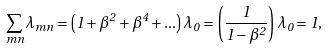<formula> <loc_0><loc_0><loc_500><loc_500>\sum _ { m n } \lambda _ { m n } = \left ( 1 + \beta ^ { 2 } + \beta ^ { 4 } + . . . \right ) \lambda _ { 0 } = \left ( \frac { 1 } { 1 - \beta ^ { 2 } } \right ) \lambda _ { 0 } = 1 ,</formula> 